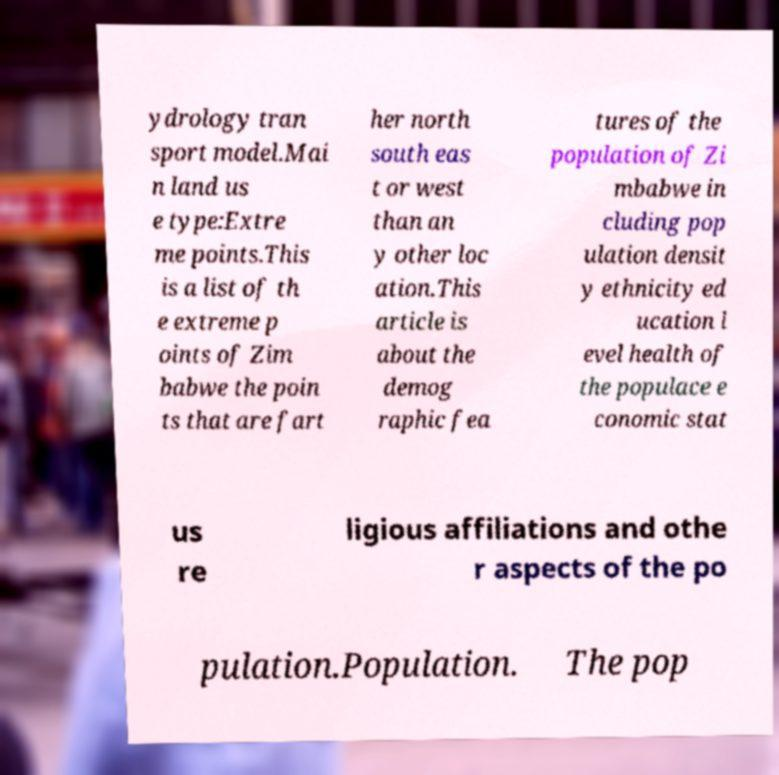Could you extract and type out the text from this image? ydrology tran sport model.Mai n land us e type:Extre me points.This is a list of th e extreme p oints of Zim babwe the poin ts that are fart her north south eas t or west than an y other loc ation.This article is about the demog raphic fea tures of the population of Zi mbabwe in cluding pop ulation densit y ethnicity ed ucation l evel health of the populace e conomic stat us re ligious affiliations and othe r aspects of the po pulation.Population. The pop 